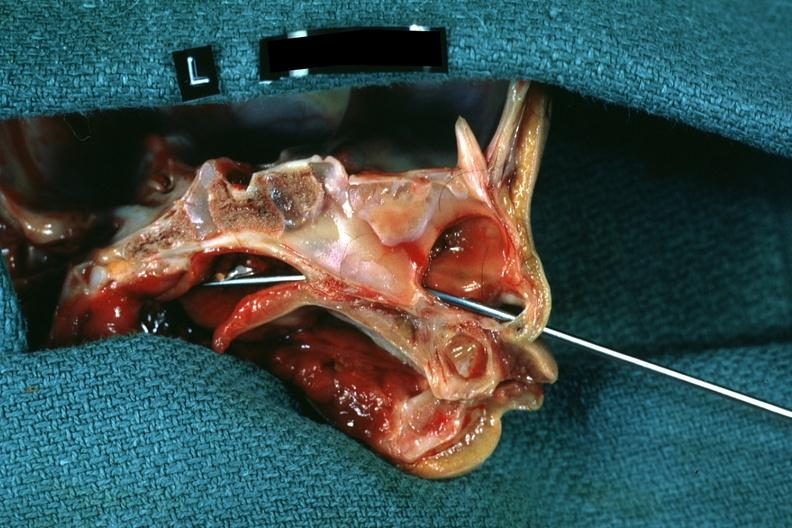does lesion show hemisection of nose left side showing patency right side was not patent?
Answer the question using a single word or phrase. No 